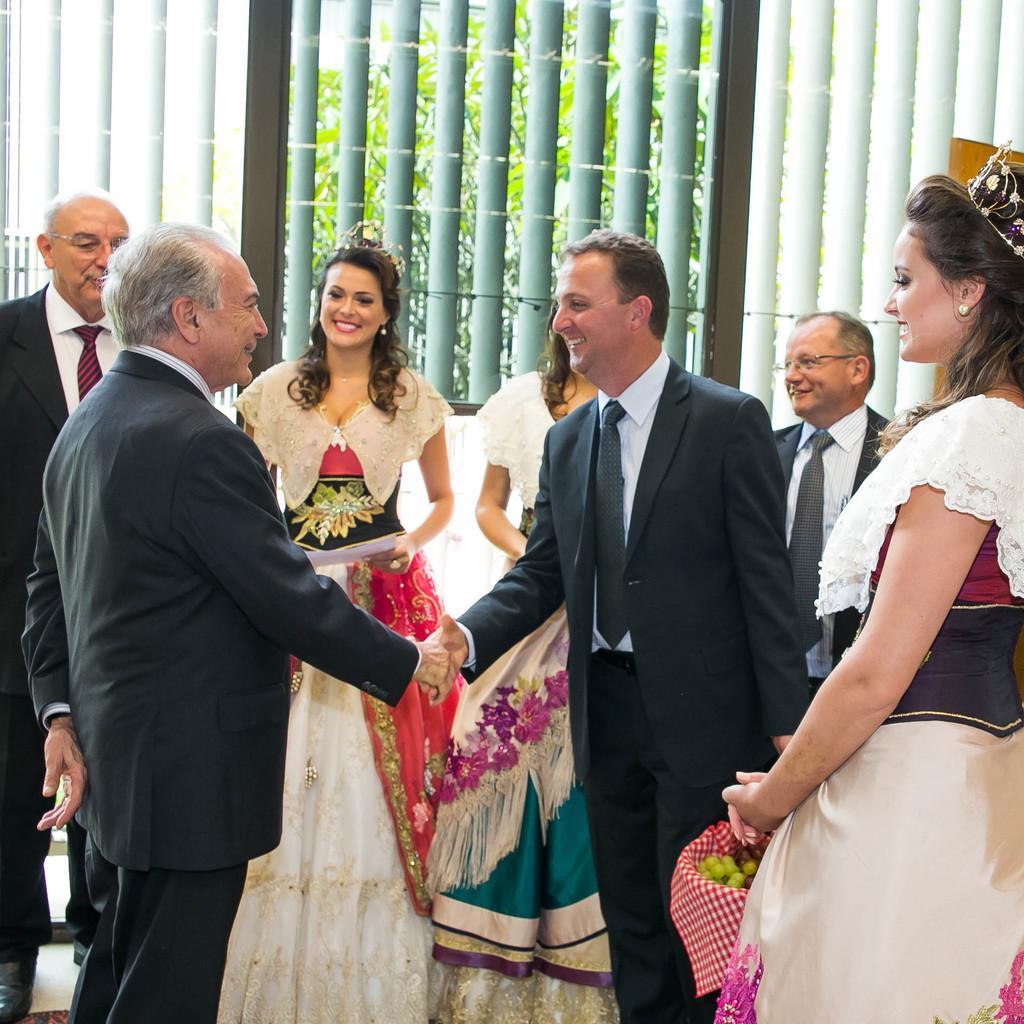In one or two sentences, can you explain what this image depicts? As we can see in the image there are few people here and there. There are three women. These three women are wearing white color dresses. Outside the window there are trees. 